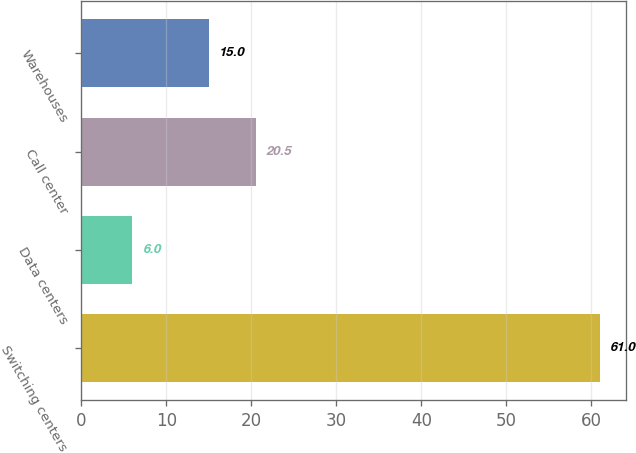Convert chart. <chart><loc_0><loc_0><loc_500><loc_500><bar_chart><fcel>Switching centers<fcel>Data centers<fcel>Call center<fcel>Warehouses<nl><fcel>61<fcel>6<fcel>20.5<fcel>15<nl></chart> 